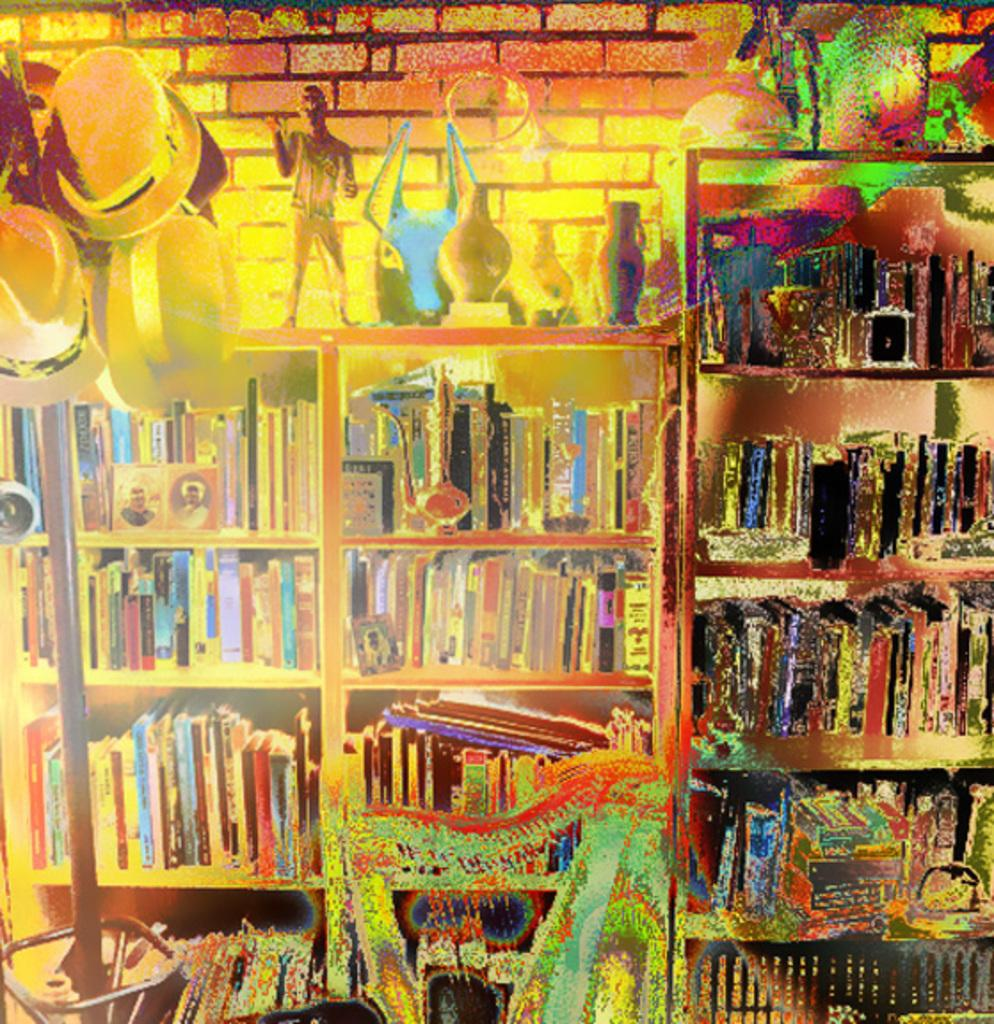What type of image is being displayed? The image is a thermal picture. What items can be seen on the racks in the image? There are books, toys, vases, boxes, and other objects on the racks. Are there any accessories visible in the image? Yes, there are hats on a stand. What can be seen in the background of the image? There is a wall visible in the image. How does the drain system work in the image? There is no drain system present in the image; it is a thermal picture of objects on racks and hats on a stand. 